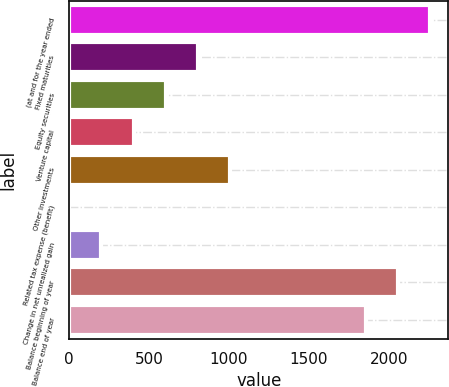Convert chart. <chart><loc_0><loc_0><loc_500><loc_500><bar_chart><fcel>(at and for the year ended<fcel>Fixed maturities<fcel>Equity securities<fcel>Venture capital<fcel>Other investments<fcel>Related tax expense (benefit)<fcel>Change in net unrealized gain<fcel>Balance beginning of year<fcel>Balance end of year<nl><fcel>2259.6<fcel>805.2<fcel>604.4<fcel>403.6<fcel>1006<fcel>2<fcel>202.8<fcel>2058.8<fcel>1858<nl></chart> 